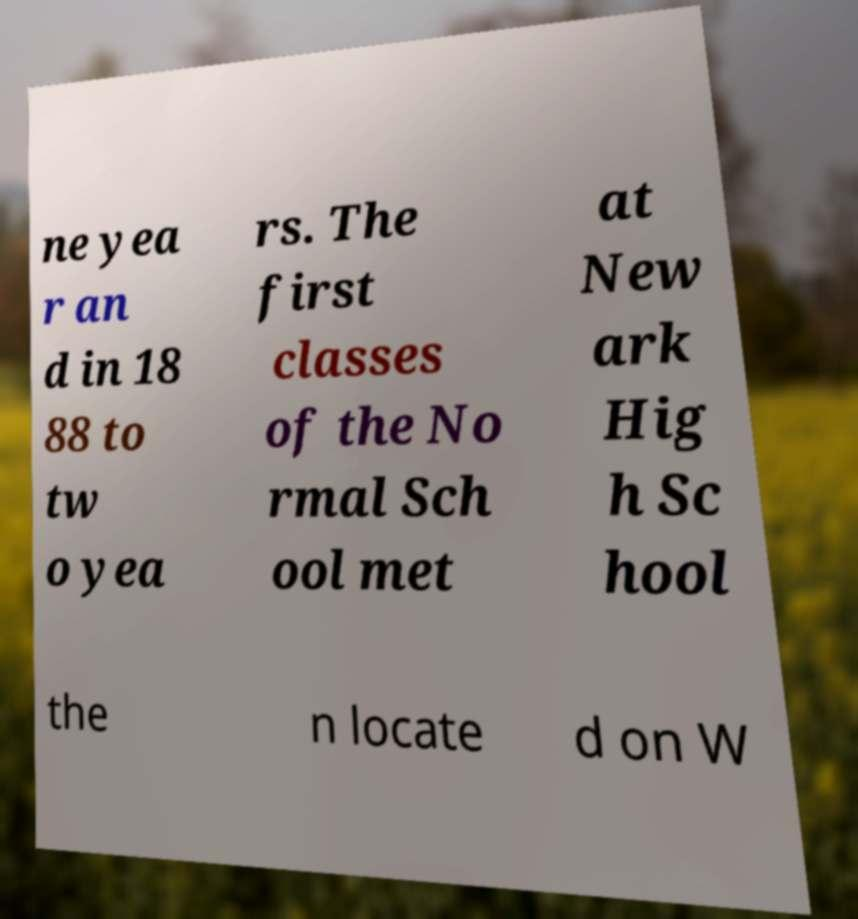For documentation purposes, I need the text within this image transcribed. Could you provide that? ne yea r an d in 18 88 to tw o yea rs. The first classes of the No rmal Sch ool met at New ark Hig h Sc hool the n locate d on W 